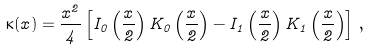<formula> <loc_0><loc_0><loc_500><loc_500>\kappa ( x ) = \frac { x ^ { 2 } } { 4 } \left [ I _ { 0 } \left ( \frac { x } { 2 } \right ) K _ { 0 } \left ( \frac { x } { 2 } \right ) - I _ { 1 } \left ( \frac { x } { 2 } \right ) K _ { 1 } \left ( \frac { x } { 2 } \right ) \right ] \, ,</formula> 